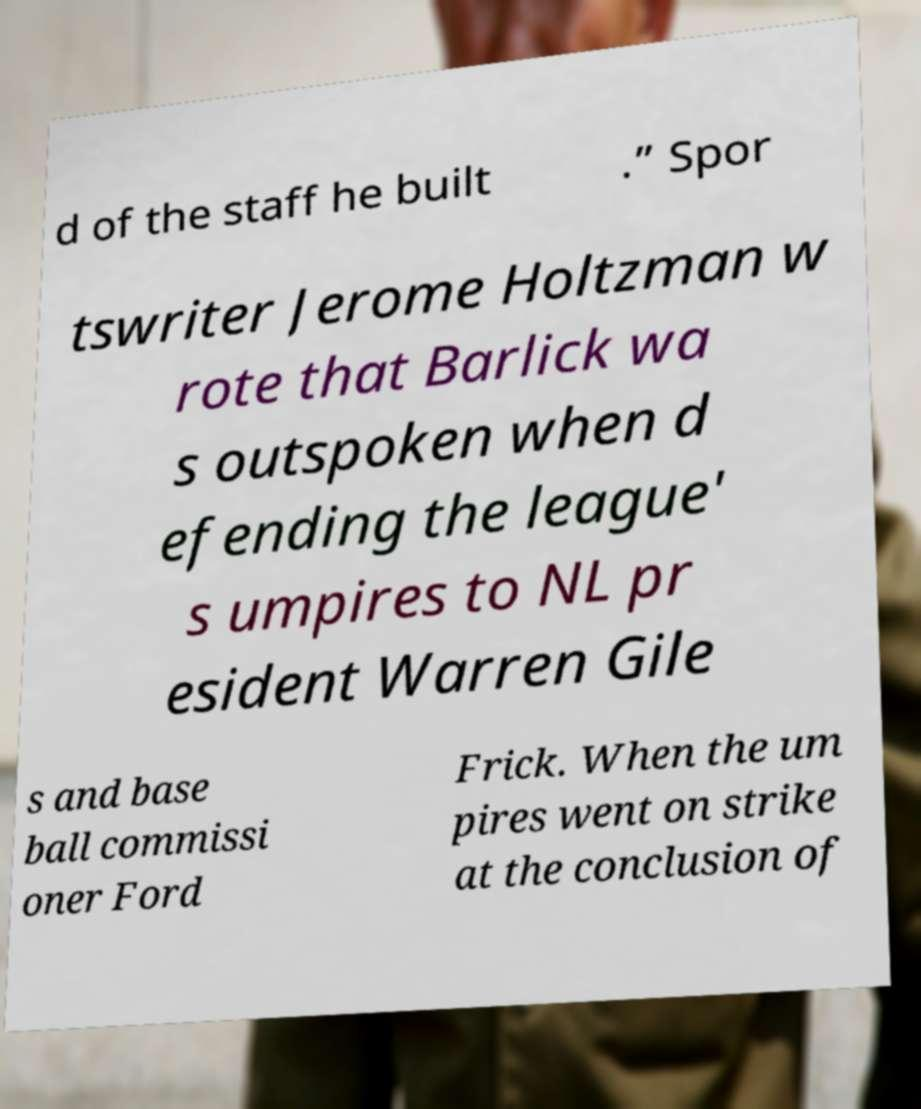Could you assist in decoding the text presented in this image and type it out clearly? d of the staff he built .” Spor tswriter Jerome Holtzman w rote that Barlick wa s outspoken when d efending the league' s umpires to NL pr esident Warren Gile s and base ball commissi oner Ford Frick. When the um pires went on strike at the conclusion of 